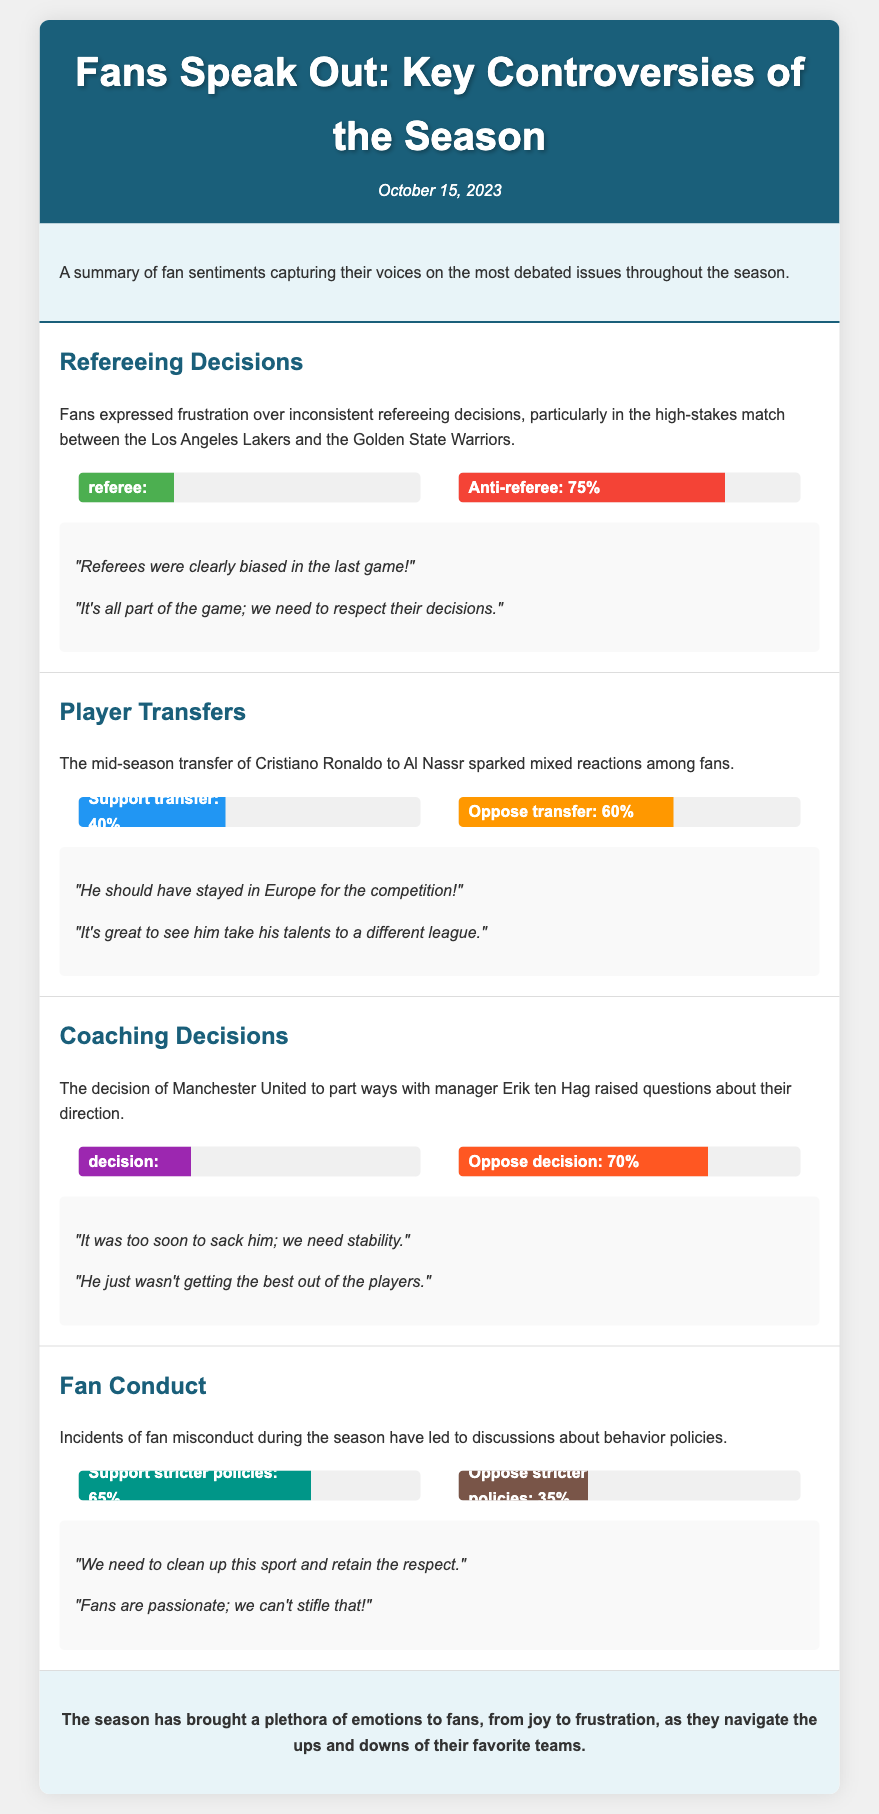What percentage of fans support stricter fan conduct policies? The document states that 65% of fans support stricter policies regarding fan conduct.
Answer: 65% What is the date of the fan poll summary? The document mentions that the fan poll summary is dated October 15, 2023.
Answer: October 15, 2023 How many fans oppose the decision to part ways with Erik ten Hag? According to the document, 70% of fans oppose the decision to part ways with Erik ten Hag.
Answer: 70% What did fans express frustration over in the refereeing decisions? Fans expressed frustration over inconsistent refereeing decisions, particularly in a high-stakes match.
Answer: Inconsistent refereeing decisions What were fans' opinions on Cristiano Ronaldo's mid-season transfer? The document highlights that 60% of fans oppose the mid-season transfer of Cristiano Ronaldo.
Answer: 60% What is the title of the document? The title of the document is "Fans Speak Out: Key Controversies of the Season".
Answer: Fans Speak Out: Key Controversies of the Season What emotion does the conclusion of the document suggest fans are experiencing this season? The conclusion indicates that fans are experiencing a mixture of emotions, including joy and frustration.
Answer: Joy and frustration What percentage of fans are pro-referee according to the poll results? The document lists that 25% of fans are pro-referee in the poll results.
Answer: 25% What was the reaction to fan misconduct during the season? Incidents of fan misconduct have led to discussions about behavior policies, indicating a need for action.
Answer: Discussions about behavior policies 